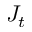<formula> <loc_0><loc_0><loc_500><loc_500>J _ { t }</formula> 